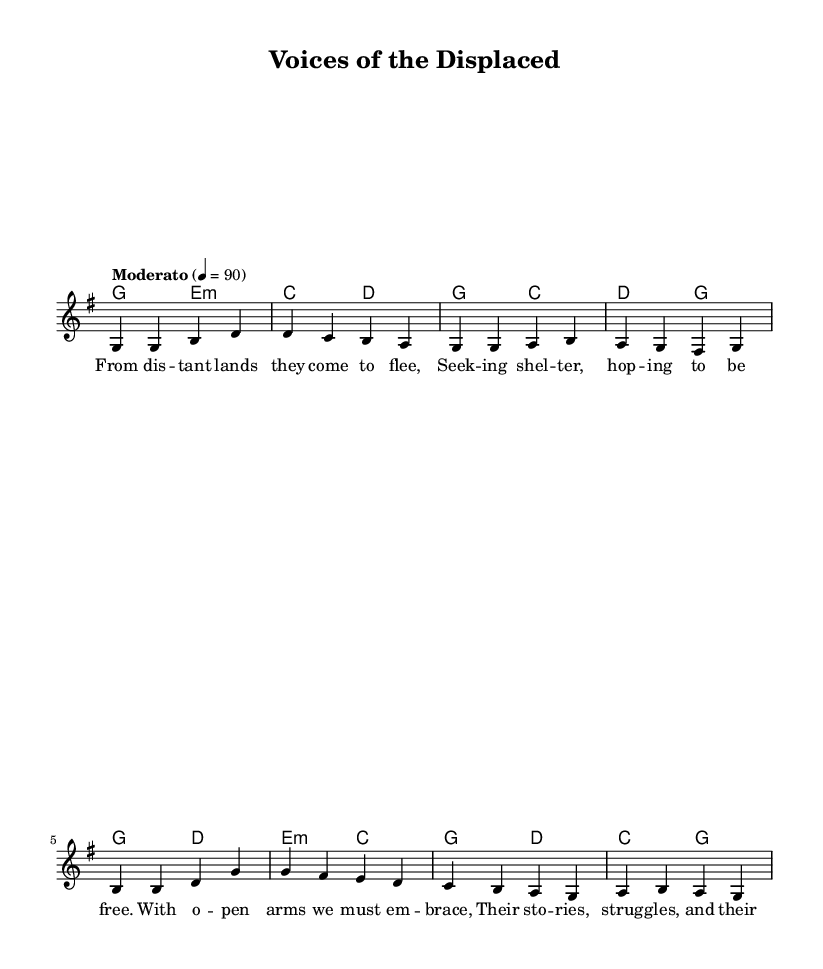What is the key signature of this music? The key signature shown at the beginning of the sheet music indicates that there are one sharp (F#), which corresponds to the key of G major.
Answer: G major What is the time signature of this piece? The time signature is found at the beginning of the music and is indicated by a "4/4," which means there are four beats in each measure and the quarter note receives one beat.
Answer: 4/4 What is the tempo marking for this song? The tempo marking, indicated above the staff, is "Moderato," which suggests a moderate speed for the performance.
Answer: Moderato How many measures are in the melody? By counting each group of notes separated by vertical lines, we can see that there are a total of 8 measures in the melody section.
Answer: 8 What is the first lyric line of the verse? The lyrics are placed below the melody, and the first line reads "From distant lands they come to flee," which is the first phrase of the verse.
Answer: From distant lands they come to flee Which chord is emphasized in the harmonies? The first chord listed in the harmonies section is G major, which is typically considered the tonic or home chord in this key.
Answer: G major What theme does this folk ballad address? The lyrics and overall message of the song focus on social justice and the struggles of displaced populations, as indicated by phrases like "Seeking shelter, hoping to be free."
Answer: Social justice 